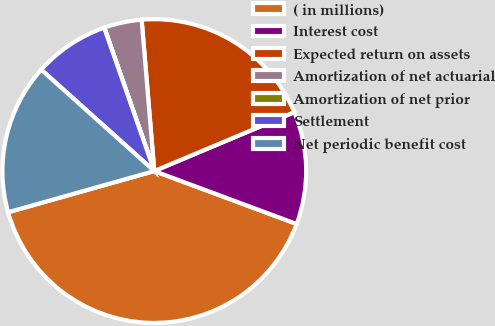<chart> <loc_0><loc_0><loc_500><loc_500><pie_chart><fcel>( in millions)<fcel>Interest cost<fcel>Expected return on assets<fcel>Amortization of net actuarial<fcel>Amortization of net prior<fcel>Settlement<fcel>Net periodic benefit cost<nl><fcel>39.96%<fcel>12.0%<fcel>19.99%<fcel>4.01%<fcel>0.02%<fcel>8.01%<fcel>16.0%<nl></chart> 